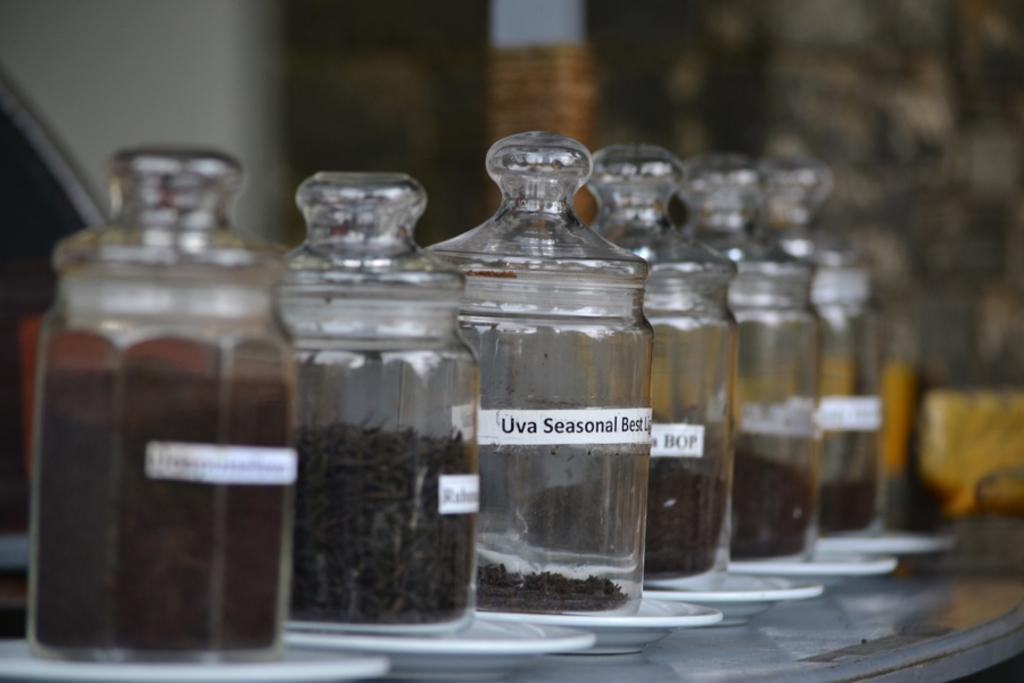<image>
Create a compact narrative representing the image presented. Spice Jars are flanking Uva Seasonal dry goods. 